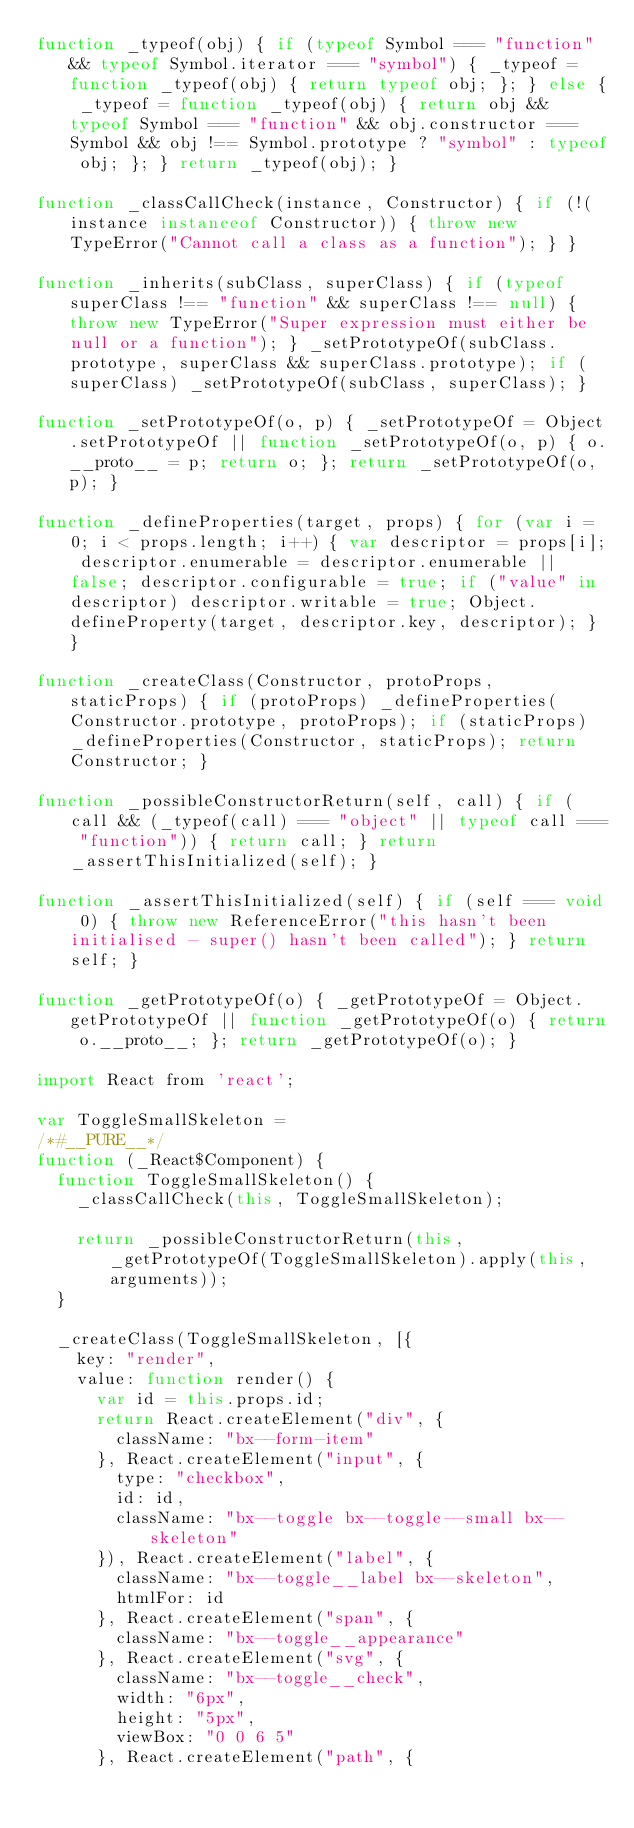Convert code to text. <code><loc_0><loc_0><loc_500><loc_500><_JavaScript_>function _typeof(obj) { if (typeof Symbol === "function" && typeof Symbol.iterator === "symbol") { _typeof = function _typeof(obj) { return typeof obj; }; } else { _typeof = function _typeof(obj) { return obj && typeof Symbol === "function" && obj.constructor === Symbol && obj !== Symbol.prototype ? "symbol" : typeof obj; }; } return _typeof(obj); }

function _classCallCheck(instance, Constructor) { if (!(instance instanceof Constructor)) { throw new TypeError("Cannot call a class as a function"); } }

function _inherits(subClass, superClass) { if (typeof superClass !== "function" && superClass !== null) { throw new TypeError("Super expression must either be null or a function"); } _setPrototypeOf(subClass.prototype, superClass && superClass.prototype); if (superClass) _setPrototypeOf(subClass, superClass); }

function _setPrototypeOf(o, p) { _setPrototypeOf = Object.setPrototypeOf || function _setPrototypeOf(o, p) { o.__proto__ = p; return o; }; return _setPrototypeOf(o, p); }

function _defineProperties(target, props) { for (var i = 0; i < props.length; i++) { var descriptor = props[i]; descriptor.enumerable = descriptor.enumerable || false; descriptor.configurable = true; if ("value" in descriptor) descriptor.writable = true; Object.defineProperty(target, descriptor.key, descriptor); } }

function _createClass(Constructor, protoProps, staticProps) { if (protoProps) _defineProperties(Constructor.prototype, protoProps); if (staticProps) _defineProperties(Constructor, staticProps); return Constructor; }

function _possibleConstructorReturn(self, call) { if (call && (_typeof(call) === "object" || typeof call === "function")) { return call; } return _assertThisInitialized(self); }

function _assertThisInitialized(self) { if (self === void 0) { throw new ReferenceError("this hasn't been initialised - super() hasn't been called"); } return self; }

function _getPrototypeOf(o) { _getPrototypeOf = Object.getPrototypeOf || function _getPrototypeOf(o) { return o.__proto__; }; return _getPrototypeOf(o); }

import React from 'react';

var ToggleSmallSkeleton =
/*#__PURE__*/
function (_React$Component) {
  function ToggleSmallSkeleton() {
    _classCallCheck(this, ToggleSmallSkeleton);

    return _possibleConstructorReturn(this, _getPrototypeOf(ToggleSmallSkeleton).apply(this, arguments));
  }

  _createClass(ToggleSmallSkeleton, [{
    key: "render",
    value: function render() {
      var id = this.props.id;
      return React.createElement("div", {
        className: "bx--form-item"
      }, React.createElement("input", {
        type: "checkbox",
        id: id,
        className: "bx--toggle bx--toggle--small bx--skeleton"
      }), React.createElement("label", {
        className: "bx--toggle__label bx--skeleton",
        htmlFor: id
      }, React.createElement("span", {
        className: "bx--toggle__appearance"
      }, React.createElement("svg", {
        className: "bx--toggle__check",
        width: "6px",
        height: "5px",
        viewBox: "0 0 6 5"
      }, React.createElement("path", {</code> 